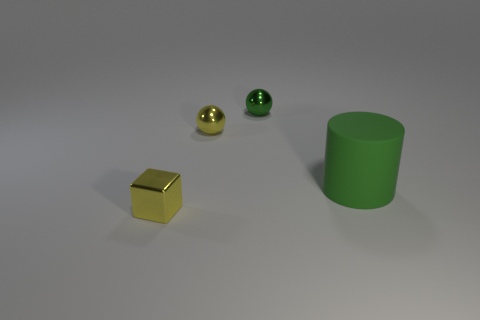Does the thing that is in front of the large cylinder have the same color as the metallic sphere in front of the small green metallic ball?
Provide a succinct answer. Yes. What number of metallic objects are green cylinders or small yellow objects?
Make the answer very short. 2. How many large green objects are behind the cylinder in front of the yellow thing that is on the right side of the small yellow block?
Keep it short and to the point. 0. There is a green ball that is made of the same material as the block; what size is it?
Ensure brevity in your answer.  Small. What number of other blocks are the same color as the small cube?
Offer a very short reply. 0. Do the yellow object behind the metal cube and the cylinder have the same size?
Provide a short and direct response. No. The thing that is both in front of the small yellow metal sphere and to the right of the tiny shiny block is what color?
Make the answer very short. Green. How many objects are gray metallic spheres or yellow shiny spheres to the left of the big green cylinder?
Your response must be concise. 1. There is a tiny ball right of the yellow thing that is behind the green thing that is in front of the yellow shiny sphere; what is it made of?
Offer a very short reply. Metal. Is there anything else that is made of the same material as the small yellow ball?
Provide a succinct answer. Yes. 